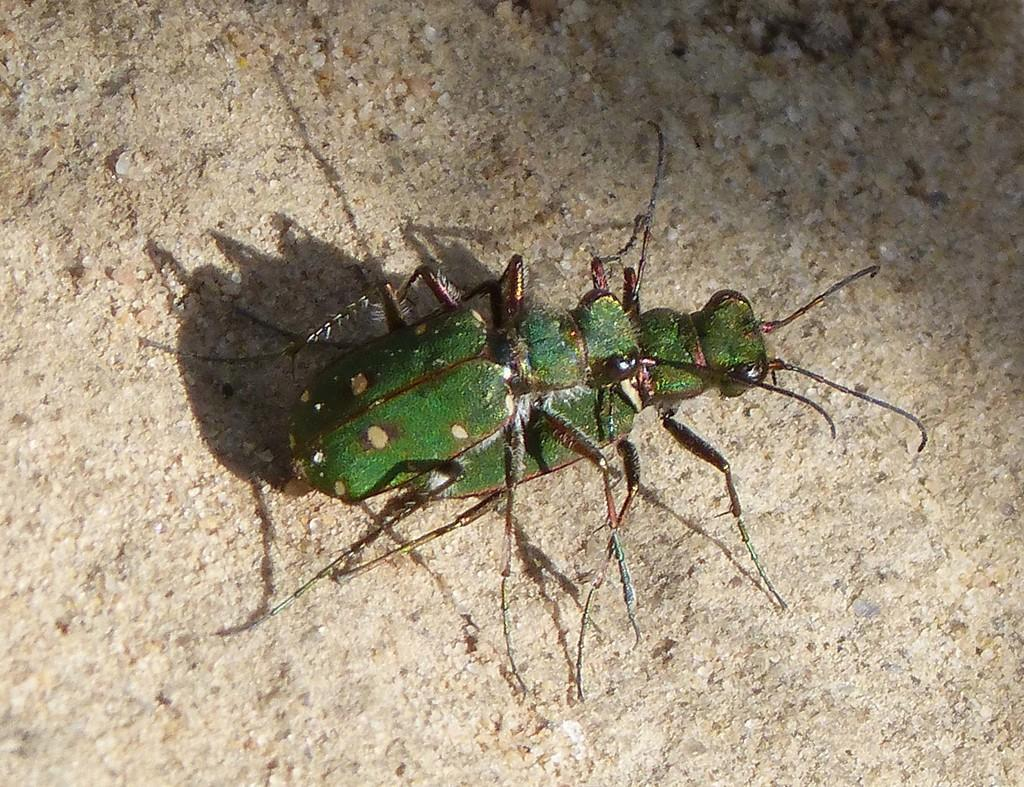How many insects are present in the image? There are two insects in the image. Where are the insects located in the image? The insects are on the ground. What effect does the desk have on the insects in the image? There is no desk present in the image, so it cannot have any effect on the insects. 